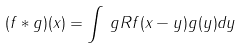Convert formula to latex. <formula><loc_0><loc_0><loc_500><loc_500>( f \ast g ) ( x ) = \int _ { \ } g R f ( x - y ) g ( y ) d y</formula> 